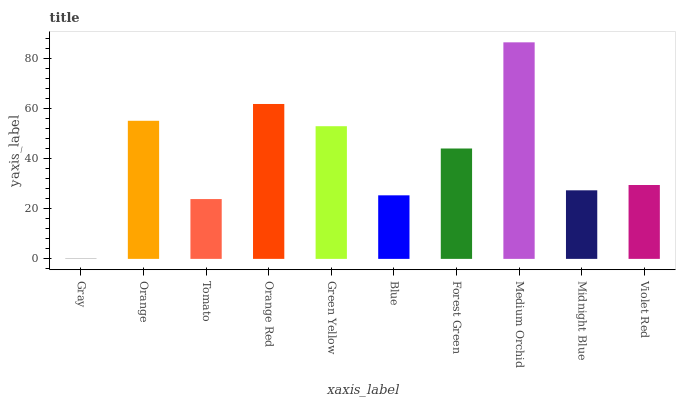Is Gray the minimum?
Answer yes or no. Yes. Is Medium Orchid the maximum?
Answer yes or no. Yes. Is Orange the minimum?
Answer yes or no. No. Is Orange the maximum?
Answer yes or no. No. Is Orange greater than Gray?
Answer yes or no. Yes. Is Gray less than Orange?
Answer yes or no. Yes. Is Gray greater than Orange?
Answer yes or no. No. Is Orange less than Gray?
Answer yes or no. No. Is Forest Green the high median?
Answer yes or no. Yes. Is Violet Red the low median?
Answer yes or no. Yes. Is Green Yellow the high median?
Answer yes or no. No. Is Orange the low median?
Answer yes or no. No. 